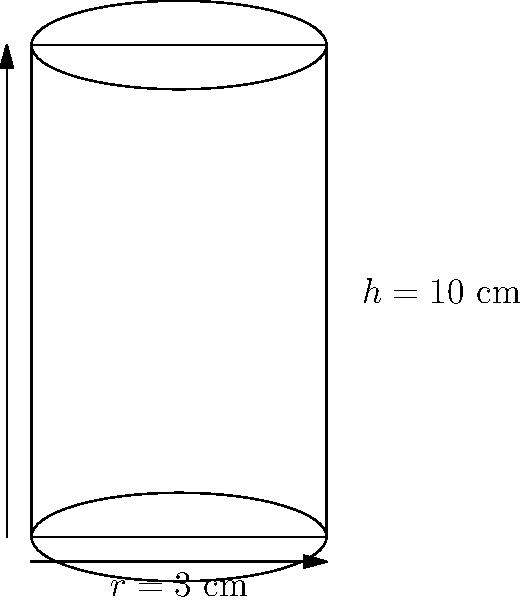As a designer of custom perfume bottles, you're working on a cylindrical bottle design. Given a height ($h$) of 10 cm and a radius ($r$) of 3 cm, calculate the volume of the perfume bottle in cubic centimeters (cm³). Use the formula $V = \pi r^2 h$, where $V$ is volume, $r$ is radius, and $h$ is height. To calculate the volume of the cylindrical perfume bottle, we'll use the formula $V = \pi r^2 h$, where:
$V$ = volume
$\pi$ ≈ 3.14159 (we'll use this approximation)
$r$ = radius = 3 cm
$h$ = height = 10 cm

Step 1: Substitute the values into the formula:
$V = \pi \cdot (3 \text{ cm})^2 \cdot 10 \text{ cm}$

Step 2: Calculate $r^2$:
$V = \pi \cdot 9 \text{ cm}^2 \cdot 10 \text{ cm}$

Step 3: Multiply all the terms:
$V = 3.14159 \cdot 9 \text{ cm}^2 \cdot 10 \text{ cm}$
$V = 282.7431 \text{ cm}^3$

Step 4: Round to two decimal places:
$V \approx 282.74 \text{ cm}^3$

Therefore, the volume of the cylindrical perfume bottle is approximately 282.74 cm³.
Answer: 282.74 cm³ 